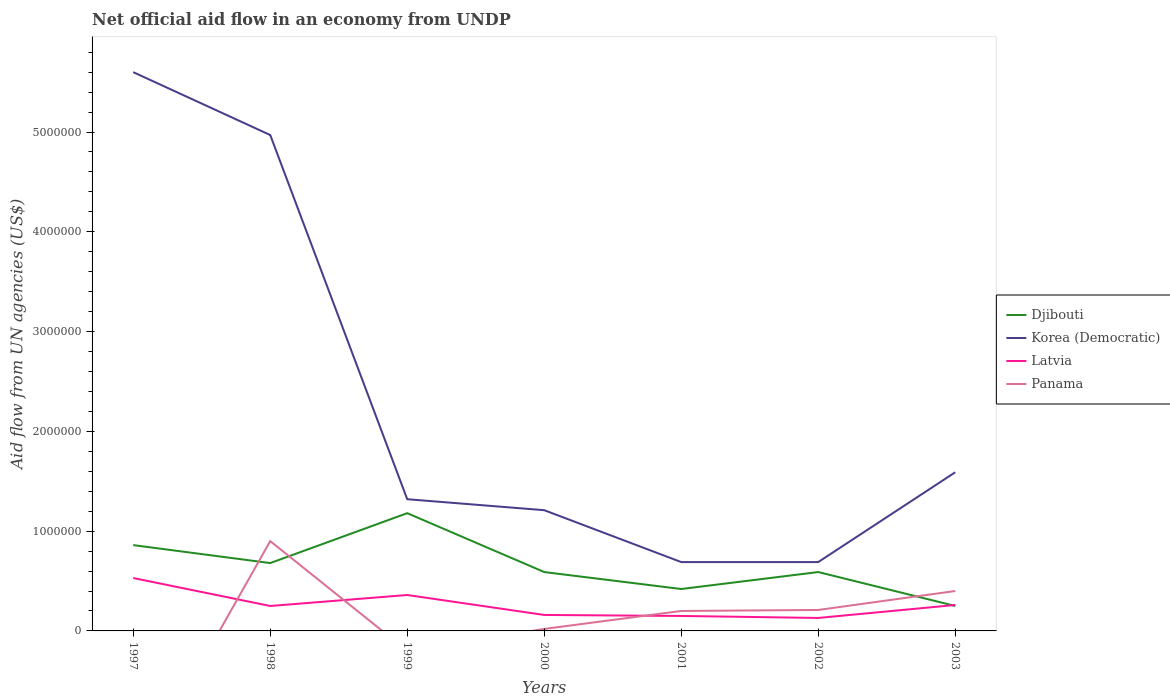How many different coloured lines are there?
Your answer should be compact. 4. What is the total net official aid flow in Korea (Democratic) in the graph?
Give a very brief answer. -9.00e+05. What is the difference between the highest and the second highest net official aid flow in Korea (Democratic)?
Give a very brief answer. 4.91e+06. Is the net official aid flow in Panama strictly greater than the net official aid flow in Latvia over the years?
Make the answer very short. No. How many years are there in the graph?
Make the answer very short. 7. What is the difference between two consecutive major ticks on the Y-axis?
Offer a terse response. 1.00e+06. Are the values on the major ticks of Y-axis written in scientific E-notation?
Your answer should be very brief. No. Where does the legend appear in the graph?
Make the answer very short. Center right. How are the legend labels stacked?
Ensure brevity in your answer.  Vertical. What is the title of the graph?
Give a very brief answer. Net official aid flow in an economy from UNDP. Does "Sudan" appear as one of the legend labels in the graph?
Give a very brief answer. No. What is the label or title of the X-axis?
Give a very brief answer. Years. What is the label or title of the Y-axis?
Your response must be concise. Aid flow from UN agencies (US$). What is the Aid flow from UN agencies (US$) in Djibouti in 1997?
Give a very brief answer. 8.60e+05. What is the Aid flow from UN agencies (US$) in Korea (Democratic) in 1997?
Ensure brevity in your answer.  5.60e+06. What is the Aid flow from UN agencies (US$) of Latvia in 1997?
Keep it short and to the point. 5.30e+05. What is the Aid flow from UN agencies (US$) in Panama in 1997?
Make the answer very short. 0. What is the Aid flow from UN agencies (US$) in Djibouti in 1998?
Offer a terse response. 6.80e+05. What is the Aid flow from UN agencies (US$) of Korea (Democratic) in 1998?
Offer a terse response. 4.97e+06. What is the Aid flow from UN agencies (US$) in Panama in 1998?
Your answer should be very brief. 9.00e+05. What is the Aid flow from UN agencies (US$) of Djibouti in 1999?
Make the answer very short. 1.18e+06. What is the Aid flow from UN agencies (US$) in Korea (Democratic) in 1999?
Your response must be concise. 1.32e+06. What is the Aid flow from UN agencies (US$) in Djibouti in 2000?
Your answer should be very brief. 5.90e+05. What is the Aid flow from UN agencies (US$) of Korea (Democratic) in 2000?
Provide a succinct answer. 1.21e+06. What is the Aid flow from UN agencies (US$) of Latvia in 2000?
Keep it short and to the point. 1.60e+05. What is the Aid flow from UN agencies (US$) of Djibouti in 2001?
Your answer should be compact. 4.20e+05. What is the Aid flow from UN agencies (US$) of Korea (Democratic) in 2001?
Make the answer very short. 6.90e+05. What is the Aid flow from UN agencies (US$) of Latvia in 2001?
Offer a very short reply. 1.50e+05. What is the Aid flow from UN agencies (US$) of Djibouti in 2002?
Your answer should be compact. 5.90e+05. What is the Aid flow from UN agencies (US$) of Korea (Democratic) in 2002?
Your response must be concise. 6.90e+05. What is the Aid flow from UN agencies (US$) in Latvia in 2002?
Ensure brevity in your answer.  1.30e+05. What is the Aid flow from UN agencies (US$) of Panama in 2002?
Ensure brevity in your answer.  2.10e+05. What is the Aid flow from UN agencies (US$) in Djibouti in 2003?
Make the answer very short. 2.50e+05. What is the Aid flow from UN agencies (US$) of Korea (Democratic) in 2003?
Provide a succinct answer. 1.59e+06. What is the Aid flow from UN agencies (US$) of Panama in 2003?
Your answer should be very brief. 4.00e+05. Across all years, what is the maximum Aid flow from UN agencies (US$) in Djibouti?
Give a very brief answer. 1.18e+06. Across all years, what is the maximum Aid flow from UN agencies (US$) of Korea (Democratic)?
Provide a short and direct response. 5.60e+06. Across all years, what is the maximum Aid flow from UN agencies (US$) in Latvia?
Your answer should be compact. 5.30e+05. Across all years, what is the maximum Aid flow from UN agencies (US$) of Panama?
Your answer should be very brief. 9.00e+05. Across all years, what is the minimum Aid flow from UN agencies (US$) in Djibouti?
Give a very brief answer. 2.50e+05. Across all years, what is the minimum Aid flow from UN agencies (US$) of Korea (Democratic)?
Your response must be concise. 6.90e+05. Across all years, what is the minimum Aid flow from UN agencies (US$) in Latvia?
Give a very brief answer. 1.30e+05. Across all years, what is the minimum Aid flow from UN agencies (US$) of Panama?
Offer a very short reply. 0. What is the total Aid flow from UN agencies (US$) of Djibouti in the graph?
Provide a succinct answer. 4.57e+06. What is the total Aid flow from UN agencies (US$) of Korea (Democratic) in the graph?
Ensure brevity in your answer.  1.61e+07. What is the total Aid flow from UN agencies (US$) in Latvia in the graph?
Give a very brief answer. 1.84e+06. What is the total Aid flow from UN agencies (US$) in Panama in the graph?
Give a very brief answer. 1.73e+06. What is the difference between the Aid flow from UN agencies (US$) in Korea (Democratic) in 1997 and that in 1998?
Provide a short and direct response. 6.30e+05. What is the difference between the Aid flow from UN agencies (US$) in Latvia in 1997 and that in 1998?
Provide a succinct answer. 2.80e+05. What is the difference between the Aid flow from UN agencies (US$) in Djibouti in 1997 and that in 1999?
Provide a succinct answer. -3.20e+05. What is the difference between the Aid flow from UN agencies (US$) in Korea (Democratic) in 1997 and that in 1999?
Make the answer very short. 4.28e+06. What is the difference between the Aid flow from UN agencies (US$) in Korea (Democratic) in 1997 and that in 2000?
Give a very brief answer. 4.39e+06. What is the difference between the Aid flow from UN agencies (US$) in Latvia in 1997 and that in 2000?
Provide a succinct answer. 3.70e+05. What is the difference between the Aid flow from UN agencies (US$) of Korea (Democratic) in 1997 and that in 2001?
Offer a very short reply. 4.91e+06. What is the difference between the Aid flow from UN agencies (US$) in Djibouti in 1997 and that in 2002?
Your answer should be compact. 2.70e+05. What is the difference between the Aid flow from UN agencies (US$) of Korea (Democratic) in 1997 and that in 2002?
Your response must be concise. 4.91e+06. What is the difference between the Aid flow from UN agencies (US$) in Latvia in 1997 and that in 2002?
Give a very brief answer. 4.00e+05. What is the difference between the Aid flow from UN agencies (US$) in Korea (Democratic) in 1997 and that in 2003?
Give a very brief answer. 4.01e+06. What is the difference between the Aid flow from UN agencies (US$) of Djibouti in 1998 and that in 1999?
Your answer should be very brief. -5.00e+05. What is the difference between the Aid flow from UN agencies (US$) of Korea (Democratic) in 1998 and that in 1999?
Make the answer very short. 3.65e+06. What is the difference between the Aid flow from UN agencies (US$) in Djibouti in 1998 and that in 2000?
Keep it short and to the point. 9.00e+04. What is the difference between the Aid flow from UN agencies (US$) of Korea (Democratic) in 1998 and that in 2000?
Keep it short and to the point. 3.76e+06. What is the difference between the Aid flow from UN agencies (US$) in Latvia in 1998 and that in 2000?
Provide a succinct answer. 9.00e+04. What is the difference between the Aid flow from UN agencies (US$) in Panama in 1998 and that in 2000?
Offer a very short reply. 8.80e+05. What is the difference between the Aid flow from UN agencies (US$) in Djibouti in 1998 and that in 2001?
Ensure brevity in your answer.  2.60e+05. What is the difference between the Aid flow from UN agencies (US$) in Korea (Democratic) in 1998 and that in 2001?
Offer a very short reply. 4.28e+06. What is the difference between the Aid flow from UN agencies (US$) of Panama in 1998 and that in 2001?
Ensure brevity in your answer.  7.00e+05. What is the difference between the Aid flow from UN agencies (US$) in Korea (Democratic) in 1998 and that in 2002?
Your answer should be compact. 4.28e+06. What is the difference between the Aid flow from UN agencies (US$) in Latvia in 1998 and that in 2002?
Ensure brevity in your answer.  1.20e+05. What is the difference between the Aid flow from UN agencies (US$) of Panama in 1998 and that in 2002?
Offer a very short reply. 6.90e+05. What is the difference between the Aid flow from UN agencies (US$) in Korea (Democratic) in 1998 and that in 2003?
Provide a short and direct response. 3.38e+06. What is the difference between the Aid flow from UN agencies (US$) of Latvia in 1998 and that in 2003?
Your response must be concise. -10000. What is the difference between the Aid flow from UN agencies (US$) of Panama in 1998 and that in 2003?
Offer a terse response. 5.00e+05. What is the difference between the Aid flow from UN agencies (US$) in Djibouti in 1999 and that in 2000?
Provide a succinct answer. 5.90e+05. What is the difference between the Aid flow from UN agencies (US$) in Korea (Democratic) in 1999 and that in 2000?
Provide a succinct answer. 1.10e+05. What is the difference between the Aid flow from UN agencies (US$) of Djibouti in 1999 and that in 2001?
Your answer should be very brief. 7.60e+05. What is the difference between the Aid flow from UN agencies (US$) of Korea (Democratic) in 1999 and that in 2001?
Your answer should be compact. 6.30e+05. What is the difference between the Aid flow from UN agencies (US$) in Djibouti in 1999 and that in 2002?
Offer a very short reply. 5.90e+05. What is the difference between the Aid flow from UN agencies (US$) of Korea (Democratic) in 1999 and that in 2002?
Keep it short and to the point. 6.30e+05. What is the difference between the Aid flow from UN agencies (US$) in Latvia in 1999 and that in 2002?
Provide a short and direct response. 2.30e+05. What is the difference between the Aid flow from UN agencies (US$) in Djibouti in 1999 and that in 2003?
Provide a succinct answer. 9.30e+05. What is the difference between the Aid flow from UN agencies (US$) of Korea (Democratic) in 1999 and that in 2003?
Make the answer very short. -2.70e+05. What is the difference between the Aid flow from UN agencies (US$) of Djibouti in 2000 and that in 2001?
Provide a short and direct response. 1.70e+05. What is the difference between the Aid flow from UN agencies (US$) in Korea (Democratic) in 2000 and that in 2001?
Ensure brevity in your answer.  5.20e+05. What is the difference between the Aid flow from UN agencies (US$) in Latvia in 2000 and that in 2001?
Keep it short and to the point. 10000. What is the difference between the Aid flow from UN agencies (US$) in Korea (Democratic) in 2000 and that in 2002?
Your response must be concise. 5.20e+05. What is the difference between the Aid flow from UN agencies (US$) in Panama in 2000 and that in 2002?
Your response must be concise. -1.90e+05. What is the difference between the Aid flow from UN agencies (US$) of Korea (Democratic) in 2000 and that in 2003?
Your answer should be very brief. -3.80e+05. What is the difference between the Aid flow from UN agencies (US$) of Panama in 2000 and that in 2003?
Offer a terse response. -3.80e+05. What is the difference between the Aid flow from UN agencies (US$) of Djibouti in 2001 and that in 2002?
Your answer should be compact. -1.70e+05. What is the difference between the Aid flow from UN agencies (US$) of Korea (Democratic) in 2001 and that in 2002?
Provide a succinct answer. 0. What is the difference between the Aid flow from UN agencies (US$) of Latvia in 2001 and that in 2002?
Make the answer very short. 2.00e+04. What is the difference between the Aid flow from UN agencies (US$) of Panama in 2001 and that in 2002?
Offer a very short reply. -10000. What is the difference between the Aid flow from UN agencies (US$) in Djibouti in 2001 and that in 2003?
Your response must be concise. 1.70e+05. What is the difference between the Aid flow from UN agencies (US$) in Korea (Democratic) in 2001 and that in 2003?
Give a very brief answer. -9.00e+05. What is the difference between the Aid flow from UN agencies (US$) in Latvia in 2001 and that in 2003?
Your answer should be very brief. -1.10e+05. What is the difference between the Aid flow from UN agencies (US$) in Korea (Democratic) in 2002 and that in 2003?
Keep it short and to the point. -9.00e+05. What is the difference between the Aid flow from UN agencies (US$) in Latvia in 2002 and that in 2003?
Provide a succinct answer. -1.30e+05. What is the difference between the Aid flow from UN agencies (US$) in Djibouti in 1997 and the Aid flow from UN agencies (US$) in Korea (Democratic) in 1998?
Your answer should be very brief. -4.11e+06. What is the difference between the Aid flow from UN agencies (US$) of Djibouti in 1997 and the Aid flow from UN agencies (US$) of Latvia in 1998?
Ensure brevity in your answer.  6.10e+05. What is the difference between the Aid flow from UN agencies (US$) in Korea (Democratic) in 1997 and the Aid flow from UN agencies (US$) in Latvia in 1998?
Make the answer very short. 5.35e+06. What is the difference between the Aid flow from UN agencies (US$) of Korea (Democratic) in 1997 and the Aid flow from UN agencies (US$) of Panama in 1998?
Your answer should be compact. 4.70e+06. What is the difference between the Aid flow from UN agencies (US$) in Latvia in 1997 and the Aid flow from UN agencies (US$) in Panama in 1998?
Your answer should be very brief. -3.70e+05. What is the difference between the Aid flow from UN agencies (US$) of Djibouti in 1997 and the Aid flow from UN agencies (US$) of Korea (Democratic) in 1999?
Give a very brief answer. -4.60e+05. What is the difference between the Aid flow from UN agencies (US$) of Djibouti in 1997 and the Aid flow from UN agencies (US$) of Latvia in 1999?
Your response must be concise. 5.00e+05. What is the difference between the Aid flow from UN agencies (US$) of Korea (Democratic) in 1997 and the Aid flow from UN agencies (US$) of Latvia in 1999?
Provide a short and direct response. 5.24e+06. What is the difference between the Aid flow from UN agencies (US$) in Djibouti in 1997 and the Aid flow from UN agencies (US$) in Korea (Democratic) in 2000?
Make the answer very short. -3.50e+05. What is the difference between the Aid flow from UN agencies (US$) of Djibouti in 1997 and the Aid flow from UN agencies (US$) of Panama in 2000?
Keep it short and to the point. 8.40e+05. What is the difference between the Aid flow from UN agencies (US$) in Korea (Democratic) in 1997 and the Aid flow from UN agencies (US$) in Latvia in 2000?
Your answer should be compact. 5.44e+06. What is the difference between the Aid flow from UN agencies (US$) of Korea (Democratic) in 1997 and the Aid flow from UN agencies (US$) of Panama in 2000?
Make the answer very short. 5.58e+06. What is the difference between the Aid flow from UN agencies (US$) in Latvia in 1997 and the Aid flow from UN agencies (US$) in Panama in 2000?
Make the answer very short. 5.10e+05. What is the difference between the Aid flow from UN agencies (US$) in Djibouti in 1997 and the Aid flow from UN agencies (US$) in Korea (Democratic) in 2001?
Your response must be concise. 1.70e+05. What is the difference between the Aid flow from UN agencies (US$) in Djibouti in 1997 and the Aid flow from UN agencies (US$) in Latvia in 2001?
Your response must be concise. 7.10e+05. What is the difference between the Aid flow from UN agencies (US$) of Korea (Democratic) in 1997 and the Aid flow from UN agencies (US$) of Latvia in 2001?
Offer a very short reply. 5.45e+06. What is the difference between the Aid flow from UN agencies (US$) of Korea (Democratic) in 1997 and the Aid flow from UN agencies (US$) of Panama in 2001?
Make the answer very short. 5.40e+06. What is the difference between the Aid flow from UN agencies (US$) in Djibouti in 1997 and the Aid flow from UN agencies (US$) in Korea (Democratic) in 2002?
Give a very brief answer. 1.70e+05. What is the difference between the Aid flow from UN agencies (US$) of Djibouti in 1997 and the Aid flow from UN agencies (US$) of Latvia in 2002?
Ensure brevity in your answer.  7.30e+05. What is the difference between the Aid flow from UN agencies (US$) of Djibouti in 1997 and the Aid flow from UN agencies (US$) of Panama in 2002?
Ensure brevity in your answer.  6.50e+05. What is the difference between the Aid flow from UN agencies (US$) in Korea (Democratic) in 1997 and the Aid flow from UN agencies (US$) in Latvia in 2002?
Give a very brief answer. 5.47e+06. What is the difference between the Aid flow from UN agencies (US$) of Korea (Democratic) in 1997 and the Aid flow from UN agencies (US$) of Panama in 2002?
Provide a succinct answer. 5.39e+06. What is the difference between the Aid flow from UN agencies (US$) of Djibouti in 1997 and the Aid flow from UN agencies (US$) of Korea (Democratic) in 2003?
Make the answer very short. -7.30e+05. What is the difference between the Aid flow from UN agencies (US$) in Djibouti in 1997 and the Aid flow from UN agencies (US$) in Latvia in 2003?
Give a very brief answer. 6.00e+05. What is the difference between the Aid flow from UN agencies (US$) in Korea (Democratic) in 1997 and the Aid flow from UN agencies (US$) in Latvia in 2003?
Your answer should be very brief. 5.34e+06. What is the difference between the Aid flow from UN agencies (US$) in Korea (Democratic) in 1997 and the Aid flow from UN agencies (US$) in Panama in 2003?
Keep it short and to the point. 5.20e+06. What is the difference between the Aid flow from UN agencies (US$) in Djibouti in 1998 and the Aid flow from UN agencies (US$) in Korea (Democratic) in 1999?
Keep it short and to the point. -6.40e+05. What is the difference between the Aid flow from UN agencies (US$) of Djibouti in 1998 and the Aid flow from UN agencies (US$) of Latvia in 1999?
Provide a short and direct response. 3.20e+05. What is the difference between the Aid flow from UN agencies (US$) of Korea (Democratic) in 1998 and the Aid flow from UN agencies (US$) of Latvia in 1999?
Your response must be concise. 4.61e+06. What is the difference between the Aid flow from UN agencies (US$) of Djibouti in 1998 and the Aid flow from UN agencies (US$) of Korea (Democratic) in 2000?
Your answer should be compact. -5.30e+05. What is the difference between the Aid flow from UN agencies (US$) in Djibouti in 1998 and the Aid flow from UN agencies (US$) in Latvia in 2000?
Ensure brevity in your answer.  5.20e+05. What is the difference between the Aid flow from UN agencies (US$) of Djibouti in 1998 and the Aid flow from UN agencies (US$) of Panama in 2000?
Keep it short and to the point. 6.60e+05. What is the difference between the Aid flow from UN agencies (US$) of Korea (Democratic) in 1998 and the Aid flow from UN agencies (US$) of Latvia in 2000?
Provide a short and direct response. 4.81e+06. What is the difference between the Aid flow from UN agencies (US$) of Korea (Democratic) in 1998 and the Aid flow from UN agencies (US$) of Panama in 2000?
Give a very brief answer. 4.95e+06. What is the difference between the Aid flow from UN agencies (US$) of Djibouti in 1998 and the Aid flow from UN agencies (US$) of Latvia in 2001?
Make the answer very short. 5.30e+05. What is the difference between the Aid flow from UN agencies (US$) in Djibouti in 1998 and the Aid flow from UN agencies (US$) in Panama in 2001?
Give a very brief answer. 4.80e+05. What is the difference between the Aid flow from UN agencies (US$) in Korea (Democratic) in 1998 and the Aid flow from UN agencies (US$) in Latvia in 2001?
Your answer should be compact. 4.82e+06. What is the difference between the Aid flow from UN agencies (US$) in Korea (Democratic) in 1998 and the Aid flow from UN agencies (US$) in Panama in 2001?
Keep it short and to the point. 4.77e+06. What is the difference between the Aid flow from UN agencies (US$) of Latvia in 1998 and the Aid flow from UN agencies (US$) of Panama in 2001?
Provide a succinct answer. 5.00e+04. What is the difference between the Aid flow from UN agencies (US$) in Djibouti in 1998 and the Aid flow from UN agencies (US$) in Korea (Democratic) in 2002?
Keep it short and to the point. -10000. What is the difference between the Aid flow from UN agencies (US$) in Djibouti in 1998 and the Aid flow from UN agencies (US$) in Latvia in 2002?
Ensure brevity in your answer.  5.50e+05. What is the difference between the Aid flow from UN agencies (US$) in Djibouti in 1998 and the Aid flow from UN agencies (US$) in Panama in 2002?
Your answer should be compact. 4.70e+05. What is the difference between the Aid flow from UN agencies (US$) in Korea (Democratic) in 1998 and the Aid flow from UN agencies (US$) in Latvia in 2002?
Your answer should be compact. 4.84e+06. What is the difference between the Aid flow from UN agencies (US$) in Korea (Democratic) in 1998 and the Aid flow from UN agencies (US$) in Panama in 2002?
Offer a very short reply. 4.76e+06. What is the difference between the Aid flow from UN agencies (US$) of Djibouti in 1998 and the Aid flow from UN agencies (US$) of Korea (Democratic) in 2003?
Give a very brief answer. -9.10e+05. What is the difference between the Aid flow from UN agencies (US$) of Djibouti in 1998 and the Aid flow from UN agencies (US$) of Latvia in 2003?
Ensure brevity in your answer.  4.20e+05. What is the difference between the Aid flow from UN agencies (US$) in Korea (Democratic) in 1998 and the Aid flow from UN agencies (US$) in Latvia in 2003?
Keep it short and to the point. 4.71e+06. What is the difference between the Aid flow from UN agencies (US$) in Korea (Democratic) in 1998 and the Aid flow from UN agencies (US$) in Panama in 2003?
Give a very brief answer. 4.57e+06. What is the difference between the Aid flow from UN agencies (US$) in Djibouti in 1999 and the Aid flow from UN agencies (US$) in Korea (Democratic) in 2000?
Make the answer very short. -3.00e+04. What is the difference between the Aid flow from UN agencies (US$) in Djibouti in 1999 and the Aid flow from UN agencies (US$) in Latvia in 2000?
Keep it short and to the point. 1.02e+06. What is the difference between the Aid flow from UN agencies (US$) of Djibouti in 1999 and the Aid flow from UN agencies (US$) of Panama in 2000?
Your answer should be compact. 1.16e+06. What is the difference between the Aid flow from UN agencies (US$) of Korea (Democratic) in 1999 and the Aid flow from UN agencies (US$) of Latvia in 2000?
Offer a very short reply. 1.16e+06. What is the difference between the Aid flow from UN agencies (US$) in Korea (Democratic) in 1999 and the Aid flow from UN agencies (US$) in Panama in 2000?
Offer a very short reply. 1.30e+06. What is the difference between the Aid flow from UN agencies (US$) in Djibouti in 1999 and the Aid flow from UN agencies (US$) in Korea (Democratic) in 2001?
Offer a terse response. 4.90e+05. What is the difference between the Aid flow from UN agencies (US$) in Djibouti in 1999 and the Aid flow from UN agencies (US$) in Latvia in 2001?
Offer a very short reply. 1.03e+06. What is the difference between the Aid flow from UN agencies (US$) of Djibouti in 1999 and the Aid flow from UN agencies (US$) of Panama in 2001?
Your answer should be compact. 9.80e+05. What is the difference between the Aid flow from UN agencies (US$) in Korea (Democratic) in 1999 and the Aid flow from UN agencies (US$) in Latvia in 2001?
Ensure brevity in your answer.  1.17e+06. What is the difference between the Aid flow from UN agencies (US$) of Korea (Democratic) in 1999 and the Aid flow from UN agencies (US$) of Panama in 2001?
Your response must be concise. 1.12e+06. What is the difference between the Aid flow from UN agencies (US$) in Latvia in 1999 and the Aid flow from UN agencies (US$) in Panama in 2001?
Offer a very short reply. 1.60e+05. What is the difference between the Aid flow from UN agencies (US$) in Djibouti in 1999 and the Aid flow from UN agencies (US$) in Latvia in 2002?
Your answer should be compact. 1.05e+06. What is the difference between the Aid flow from UN agencies (US$) of Djibouti in 1999 and the Aid flow from UN agencies (US$) of Panama in 2002?
Offer a terse response. 9.70e+05. What is the difference between the Aid flow from UN agencies (US$) in Korea (Democratic) in 1999 and the Aid flow from UN agencies (US$) in Latvia in 2002?
Offer a terse response. 1.19e+06. What is the difference between the Aid flow from UN agencies (US$) of Korea (Democratic) in 1999 and the Aid flow from UN agencies (US$) of Panama in 2002?
Your response must be concise. 1.11e+06. What is the difference between the Aid flow from UN agencies (US$) of Djibouti in 1999 and the Aid flow from UN agencies (US$) of Korea (Democratic) in 2003?
Provide a succinct answer. -4.10e+05. What is the difference between the Aid flow from UN agencies (US$) of Djibouti in 1999 and the Aid flow from UN agencies (US$) of Latvia in 2003?
Ensure brevity in your answer.  9.20e+05. What is the difference between the Aid flow from UN agencies (US$) in Djibouti in 1999 and the Aid flow from UN agencies (US$) in Panama in 2003?
Ensure brevity in your answer.  7.80e+05. What is the difference between the Aid flow from UN agencies (US$) in Korea (Democratic) in 1999 and the Aid flow from UN agencies (US$) in Latvia in 2003?
Give a very brief answer. 1.06e+06. What is the difference between the Aid flow from UN agencies (US$) in Korea (Democratic) in 1999 and the Aid flow from UN agencies (US$) in Panama in 2003?
Provide a succinct answer. 9.20e+05. What is the difference between the Aid flow from UN agencies (US$) of Djibouti in 2000 and the Aid flow from UN agencies (US$) of Latvia in 2001?
Your answer should be very brief. 4.40e+05. What is the difference between the Aid flow from UN agencies (US$) in Korea (Democratic) in 2000 and the Aid flow from UN agencies (US$) in Latvia in 2001?
Offer a terse response. 1.06e+06. What is the difference between the Aid flow from UN agencies (US$) of Korea (Democratic) in 2000 and the Aid flow from UN agencies (US$) of Panama in 2001?
Keep it short and to the point. 1.01e+06. What is the difference between the Aid flow from UN agencies (US$) of Latvia in 2000 and the Aid flow from UN agencies (US$) of Panama in 2001?
Provide a short and direct response. -4.00e+04. What is the difference between the Aid flow from UN agencies (US$) of Djibouti in 2000 and the Aid flow from UN agencies (US$) of Korea (Democratic) in 2002?
Your answer should be compact. -1.00e+05. What is the difference between the Aid flow from UN agencies (US$) of Djibouti in 2000 and the Aid flow from UN agencies (US$) of Panama in 2002?
Ensure brevity in your answer.  3.80e+05. What is the difference between the Aid flow from UN agencies (US$) in Korea (Democratic) in 2000 and the Aid flow from UN agencies (US$) in Latvia in 2002?
Keep it short and to the point. 1.08e+06. What is the difference between the Aid flow from UN agencies (US$) in Korea (Democratic) in 2000 and the Aid flow from UN agencies (US$) in Latvia in 2003?
Your answer should be compact. 9.50e+05. What is the difference between the Aid flow from UN agencies (US$) of Korea (Democratic) in 2000 and the Aid flow from UN agencies (US$) of Panama in 2003?
Your answer should be compact. 8.10e+05. What is the difference between the Aid flow from UN agencies (US$) in Latvia in 2000 and the Aid flow from UN agencies (US$) in Panama in 2003?
Your response must be concise. -2.40e+05. What is the difference between the Aid flow from UN agencies (US$) of Djibouti in 2001 and the Aid flow from UN agencies (US$) of Korea (Democratic) in 2002?
Offer a terse response. -2.70e+05. What is the difference between the Aid flow from UN agencies (US$) in Korea (Democratic) in 2001 and the Aid flow from UN agencies (US$) in Latvia in 2002?
Make the answer very short. 5.60e+05. What is the difference between the Aid flow from UN agencies (US$) in Korea (Democratic) in 2001 and the Aid flow from UN agencies (US$) in Panama in 2002?
Give a very brief answer. 4.80e+05. What is the difference between the Aid flow from UN agencies (US$) of Latvia in 2001 and the Aid flow from UN agencies (US$) of Panama in 2002?
Give a very brief answer. -6.00e+04. What is the difference between the Aid flow from UN agencies (US$) of Djibouti in 2001 and the Aid flow from UN agencies (US$) of Korea (Democratic) in 2003?
Offer a terse response. -1.17e+06. What is the difference between the Aid flow from UN agencies (US$) of Korea (Democratic) in 2001 and the Aid flow from UN agencies (US$) of Latvia in 2003?
Provide a succinct answer. 4.30e+05. What is the difference between the Aid flow from UN agencies (US$) of Korea (Democratic) in 2001 and the Aid flow from UN agencies (US$) of Panama in 2003?
Ensure brevity in your answer.  2.90e+05. What is the difference between the Aid flow from UN agencies (US$) in Latvia in 2001 and the Aid flow from UN agencies (US$) in Panama in 2003?
Provide a succinct answer. -2.50e+05. What is the difference between the Aid flow from UN agencies (US$) in Djibouti in 2002 and the Aid flow from UN agencies (US$) in Latvia in 2003?
Provide a short and direct response. 3.30e+05. What is the difference between the Aid flow from UN agencies (US$) of Korea (Democratic) in 2002 and the Aid flow from UN agencies (US$) of Panama in 2003?
Your response must be concise. 2.90e+05. What is the average Aid flow from UN agencies (US$) in Djibouti per year?
Your answer should be very brief. 6.53e+05. What is the average Aid flow from UN agencies (US$) of Korea (Democratic) per year?
Your answer should be compact. 2.30e+06. What is the average Aid flow from UN agencies (US$) of Latvia per year?
Provide a short and direct response. 2.63e+05. What is the average Aid flow from UN agencies (US$) of Panama per year?
Give a very brief answer. 2.47e+05. In the year 1997, what is the difference between the Aid flow from UN agencies (US$) of Djibouti and Aid flow from UN agencies (US$) of Korea (Democratic)?
Give a very brief answer. -4.74e+06. In the year 1997, what is the difference between the Aid flow from UN agencies (US$) in Korea (Democratic) and Aid flow from UN agencies (US$) in Latvia?
Provide a short and direct response. 5.07e+06. In the year 1998, what is the difference between the Aid flow from UN agencies (US$) of Djibouti and Aid flow from UN agencies (US$) of Korea (Democratic)?
Your answer should be compact. -4.29e+06. In the year 1998, what is the difference between the Aid flow from UN agencies (US$) of Djibouti and Aid flow from UN agencies (US$) of Latvia?
Give a very brief answer. 4.30e+05. In the year 1998, what is the difference between the Aid flow from UN agencies (US$) in Djibouti and Aid flow from UN agencies (US$) in Panama?
Ensure brevity in your answer.  -2.20e+05. In the year 1998, what is the difference between the Aid flow from UN agencies (US$) of Korea (Democratic) and Aid flow from UN agencies (US$) of Latvia?
Ensure brevity in your answer.  4.72e+06. In the year 1998, what is the difference between the Aid flow from UN agencies (US$) of Korea (Democratic) and Aid flow from UN agencies (US$) of Panama?
Provide a short and direct response. 4.07e+06. In the year 1998, what is the difference between the Aid flow from UN agencies (US$) of Latvia and Aid flow from UN agencies (US$) of Panama?
Ensure brevity in your answer.  -6.50e+05. In the year 1999, what is the difference between the Aid flow from UN agencies (US$) of Djibouti and Aid flow from UN agencies (US$) of Latvia?
Your response must be concise. 8.20e+05. In the year 1999, what is the difference between the Aid flow from UN agencies (US$) in Korea (Democratic) and Aid flow from UN agencies (US$) in Latvia?
Keep it short and to the point. 9.60e+05. In the year 2000, what is the difference between the Aid flow from UN agencies (US$) of Djibouti and Aid flow from UN agencies (US$) of Korea (Democratic)?
Your answer should be very brief. -6.20e+05. In the year 2000, what is the difference between the Aid flow from UN agencies (US$) in Djibouti and Aid flow from UN agencies (US$) in Latvia?
Keep it short and to the point. 4.30e+05. In the year 2000, what is the difference between the Aid flow from UN agencies (US$) in Djibouti and Aid flow from UN agencies (US$) in Panama?
Keep it short and to the point. 5.70e+05. In the year 2000, what is the difference between the Aid flow from UN agencies (US$) in Korea (Democratic) and Aid flow from UN agencies (US$) in Latvia?
Your answer should be very brief. 1.05e+06. In the year 2000, what is the difference between the Aid flow from UN agencies (US$) of Korea (Democratic) and Aid flow from UN agencies (US$) of Panama?
Provide a succinct answer. 1.19e+06. In the year 2000, what is the difference between the Aid flow from UN agencies (US$) of Latvia and Aid flow from UN agencies (US$) of Panama?
Make the answer very short. 1.40e+05. In the year 2001, what is the difference between the Aid flow from UN agencies (US$) of Djibouti and Aid flow from UN agencies (US$) of Latvia?
Give a very brief answer. 2.70e+05. In the year 2001, what is the difference between the Aid flow from UN agencies (US$) of Djibouti and Aid flow from UN agencies (US$) of Panama?
Provide a short and direct response. 2.20e+05. In the year 2001, what is the difference between the Aid flow from UN agencies (US$) in Korea (Democratic) and Aid flow from UN agencies (US$) in Latvia?
Offer a very short reply. 5.40e+05. In the year 2002, what is the difference between the Aid flow from UN agencies (US$) in Djibouti and Aid flow from UN agencies (US$) in Latvia?
Keep it short and to the point. 4.60e+05. In the year 2002, what is the difference between the Aid flow from UN agencies (US$) in Djibouti and Aid flow from UN agencies (US$) in Panama?
Offer a terse response. 3.80e+05. In the year 2002, what is the difference between the Aid flow from UN agencies (US$) in Korea (Democratic) and Aid flow from UN agencies (US$) in Latvia?
Keep it short and to the point. 5.60e+05. In the year 2002, what is the difference between the Aid flow from UN agencies (US$) of Latvia and Aid flow from UN agencies (US$) of Panama?
Make the answer very short. -8.00e+04. In the year 2003, what is the difference between the Aid flow from UN agencies (US$) of Djibouti and Aid flow from UN agencies (US$) of Korea (Democratic)?
Provide a short and direct response. -1.34e+06. In the year 2003, what is the difference between the Aid flow from UN agencies (US$) of Djibouti and Aid flow from UN agencies (US$) of Latvia?
Offer a terse response. -10000. In the year 2003, what is the difference between the Aid flow from UN agencies (US$) in Djibouti and Aid flow from UN agencies (US$) in Panama?
Offer a terse response. -1.50e+05. In the year 2003, what is the difference between the Aid flow from UN agencies (US$) in Korea (Democratic) and Aid flow from UN agencies (US$) in Latvia?
Your answer should be very brief. 1.33e+06. In the year 2003, what is the difference between the Aid flow from UN agencies (US$) in Korea (Democratic) and Aid flow from UN agencies (US$) in Panama?
Give a very brief answer. 1.19e+06. What is the ratio of the Aid flow from UN agencies (US$) in Djibouti in 1997 to that in 1998?
Provide a succinct answer. 1.26. What is the ratio of the Aid flow from UN agencies (US$) of Korea (Democratic) in 1997 to that in 1998?
Keep it short and to the point. 1.13. What is the ratio of the Aid flow from UN agencies (US$) of Latvia in 1997 to that in 1998?
Ensure brevity in your answer.  2.12. What is the ratio of the Aid flow from UN agencies (US$) in Djibouti in 1997 to that in 1999?
Offer a terse response. 0.73. What is the ratio of the Aid flow from UN agencies (US$) of Korea (Democratic) in 1997 to that in 1999?
Give a very brief answer. 4.24. What is the ratio of the Aid flow from UN agencies (US$) in Latvia in 1997 to that in 1999?
Make the answer very short. 1.47. What is the ratio of the Aid flow from UN agencies (US$) in Djibouti in 1997 to that in 2000?
Your answer should be very brief. 1.46. What is the ratio of the Aid flow from UN agencies (US$) in Korea (Democratic) in 1997 to that in 2000?
Ensure brevity in your answer.  4.63. What is the ratio of the Aid flow from UN agencies (US$) of Latvia in 1997 to that in 2000?
Give a very brief answer. 3.31. What is the ratio of the Aid flow from UN agencies (US$) of Djibouti in 1997 to that in 2001?
Provide a succinct answer. 2.05. What is the ratio of the Aid flow from UN agencies (US$) in Korea (Democratic) in 1997 to that in 2001?
Your answer should be compact. 8.12. What is the ratio of the Aid flow from UN agencies (US$) in Latvia in 1997 to that in 2001?
Your answer should be very brief. 3.53. What is the ratio of the Aid flow from UN agencies (US$) of Djibouti in 1997 to that in 2002?
Keep it short and to the point. 1.46. What is the ratio of the Aid flow from UN agencies (US$) in Korea (Democratic) in 1997 to that in 2002?
Your answer should be very brief. 8.12. What is the ratio of the Aid flow from UN agencies (US$) in Latvia in 1997 to that in 2002?
Provide a succinct answer. 4.08. What is the ratio of the Aid flow from UN agencies (US$) of Djibouti in 1997 to that in 2003?
Your response must be concise. 3.44. What is the ratio of the Aid flow from UN agencies (US$) of Korea (Democratic) in 1997 to that in 2003?
Provide a short and direct response. 3.52. What is the ratio of the Aid flow from UN agencies (US$) in Latvia in 1997 to that in 2003?
Your response must be concise. 2.04. What is the ratio of the Aid flow from UN agencies (US$) in Djibouti in 1998 to that in 1999?
Make the answer very short. 0.58. What is the ratio of the Aid flow from UN agencies (US$) in Korea (Democratic) in 1998 to that in 1999?
Give a very brief answer. 3.77. What is the ratio of the Aid flow from UN agencies (US$) in Latvia in 1998 to that in 1999?
Provide a succinct answer. 0.69. What is the ratio of the Aid flow from UN agencies (US$) of Djibouti in 1998 to that in 2000?
Your answer should be very brief. 1.15. What is the ratio of the Aid flow from UN agencies (US$) in Korea (Democratic) in 1998 to that in 2000?
Ensure brevity in your answer.  4.11. What is the ratio of the Aid flow from UN agencies (US$) in Latvia in 1998 to that in 2000?
Give a very brief answer. 1.56. What is the ratio of the Aid flow from UN agencies (US$) in Panama in 1998 to that in 2000?
Give a very brief answer. 45. What is the ratio of the Aid flow from UN agencies (US$) in Djibouti in 1998 to that in 2001?
Provide a short and direct response. 1.62. What is the ratio of the Aid flow from UN agencies (US$) in Korea (Democratic) in 1998 to that in 2001?
Your answer should be compact. 7.2. What is the ratio of the Aid flow from UN agencies (US$) in Latvia in 1998 to that in 2001?
Your answer should be very brief. 1.67. What is the ratio of the Aid flow from UN agencies (US$) of Panama in 1998 to that in 2001?
Provide a succinct answer. 4.5. What is the ratio of the Aid flow from UN agencies (US$) in Djibouti in 1998 to that in 2002?
Provide a succinct answer. 1.15. What is the ratio of the Aid flow from UN agencies (US$) in Korea (Democratic) in 1998 to that in 2002?
Give a very brief answer. 7.2. What is the ratio of the Aid flow from UN agencies (US$) of Latvia in 1998 to that in 2002?
Keep it short and to the point. 1.92. What is the ratio of the Aid flow from UN agencies (US$) in Panama in 1998 to that in 2002?
Provide a short and direct response. 4.29. What is the ratio of the Aid flow from UN agencies (US$) of Djibouti in 1998 to that in 2003?
Your answer should be very brief. 2.72. What is the ratio of the Aid flow from UN agencies (US$) of Korea (Democratic) in 1998 to that in 2003?
Your response must be concise. 3.13. What is the ratio of the Aid flow from UN agencies (US$) in Latvia in 1998 to that in 2003?
Give a very brief answer. 0.96. What is the ratio of the Aid flow from UN agencies (US$) in Panama in 1998 to that in 2003?
Offer a terse response. 2.25. What is the ratio of the Aid flow from UN agencies (US$) of Djibouti in 1999 to that in 2000?
Give a very brief answer. 2. What is the ratio of the Aid flow from UN agencies (US$) of Latvia in 1999 to that in 2000?
Keep it short and to the point. 2.25. What is the ratio of the Aid flow from UN agencies (US$) in Djibouti in 1999 to that in 2001?
Your answer should be compact. 2.81. What is the ratio of the Aid flow from UN agencies (US$) in Korea (Democratic) in 1999 to that in 2001?
Your answer should be compact. 1.91. What is the ratio of the Aid flow from UN agencies (US$) of Djibouti in 1999 to that in 2002?
Your answer should be very brief. 2. What is the ratio of the Aid flow from UN agencies (US$) of Korea (Democratic) in 1999 to that in 2002?
Make the answer very short. 1.91. What is the ratio of the Aid flow from UN agencies (US$) in Latvia in 1999 to that in 2002?
Provide a short and direct response. 2.77. What is the ratio of the Aid flow from UN agencies (US$) in Djibouti in 1999 to that in 2003?
Keep it short and to the point. 4.72. What is the ratio of the Aid flow from UN agencies (US$) of Korea (Democratic) in 1999 to that in 2003?
Keep it short and to the point. 0.83. What is the ratio of the Aid flow from UN agencies (US$) in Latvia in 1999 to that in 2003?
Your answer should be compact. 1.38. What is the ratio of the Aid flow from UN agencies (US$) of Djibouti in 2000 to that in 2001?
Provide a succinct answer. 1.4. What is the ratio of the Aid flow from UN agencies (US$) in Korea (Democratic) in 2000 to that in 2001?
Provide a succinct answer. 1.75. What is the ratio of the Aid flow from UN agencies (US$) in Latvia in 2000 to that in 2001?
Provide a succinct answer. 1.07. What is the ratio of the Aid flow from UN agencies (US$) of Djibouti in 2000 to that in 2002?
Provide a succinct answer. 1. What is the ratio of the Aid flow from UN agencies (US$) in Korea (Democratic) in 2000 to that in 2002?
Your response must be concise. 1.75. What is the ratio of the Aid flow from UN agencies (US$) of Latvia in 2000 to that in 2002?
Your response must be concise. 1.23. What is the ratio of the Aid flow from UN agencies (US$) in Panama in 2000 to that in 2002?
Offer a terse response. 0.1. What is the ratio of the Aid flow from UN agencies (US$) in Djibouti in 2000 to that in 2003?
Keep it short and to the point. 2.36. What is the ratio of the Aid flow from UN agencies (US$) of Korea (Democratic) in 2000 to that in 2003?
Offer a terse response. 0.76. What is the ratio of the Aid flow from UN agencies (US$) of Latvia in 2000 to that in 2003?
Make the answer very short. 0.62. What is the ratio of the Aid flow from UN agencies (US$) of Panama in 2000 to that in 2003?
Offer a terse response. 0.05. What is the ratio of the Aid flow from UN agencies (US$) in Djibouti in 2001 to that in 2002?
Make the answer very short. 0.71. What is the ratio of the Aid flow from UN agencies (US$) in Korea (Democratic) in 2001 to that in 2002?
Offer a very short reply. 1. What is the ratio of the Aid flow from UN agencies (US$) of Latvia in 2001 to that in 2002?
Provide a short and direct response. 1.15. What is the ratio of the Aid flow from UN agencies (US$) of Panama in 2001 to that in 2002?
Your answer should be compact. 0.95. What is the ratio of the Aid flow from UN agencies (US$) of Djibouti in 2001 to that in 2003?
Keep it short and to the point. 1.68. What is the ratio of the Aid flow from UN agencies (US$) in Korea (Democratic) in 2001 to that in 2003?
Give a very brief answer. 0.43. What is the ratio of the Aid flow from UN agencies (US$) of Latvia in 2001 to that in 2003?
Keep it short and to the point. 0.58. What is the ratio of the Aid flow from UN agencies (US$) of Djibouti in 2002 to that in 2003?
Offer a very short reply. 2.36. What is the ratio of the Aid flow from UN agencies (US$) in Korea (Democratic) in 2002 to that in 2003?
Your answer should be very brief. 0.43. What is the ratio of the Aid flow from UN agencies (US$) in Panama in 2002 to that in 2003?
Your answer should be very brief. 0.53. What is the difference between the highest and the second highest Aid flow from UN agencies (US$) of Korea (Democratic)?
Ensure brevity in your answer.  6.30e+05. What is the difference between the highest and the second highest Aid flow from UN agencies (US$) of Latvia?
Provide a succinct answer. 1.70e+05. What is the difference between the highest and the second highest Aid flow from UN agencies (US$) of Panama?
Provide a succinct answer. 5.00e+05. What is the difference between the highest and the lowest Aid flow from UN agencies (US$) of Djibouti?
Provide a succinct answer. 9.30e+05. What is the difference between the highest and the lowest Aid flow from UN agencies (US$) in Korea (Democratic)?
Give a very brief answer. 4.91e+06. What is the difference between the highest and the lowest Aid flow from UN agencies (US$) of Latvia?
Make the answer very short. 4.00e+05. 